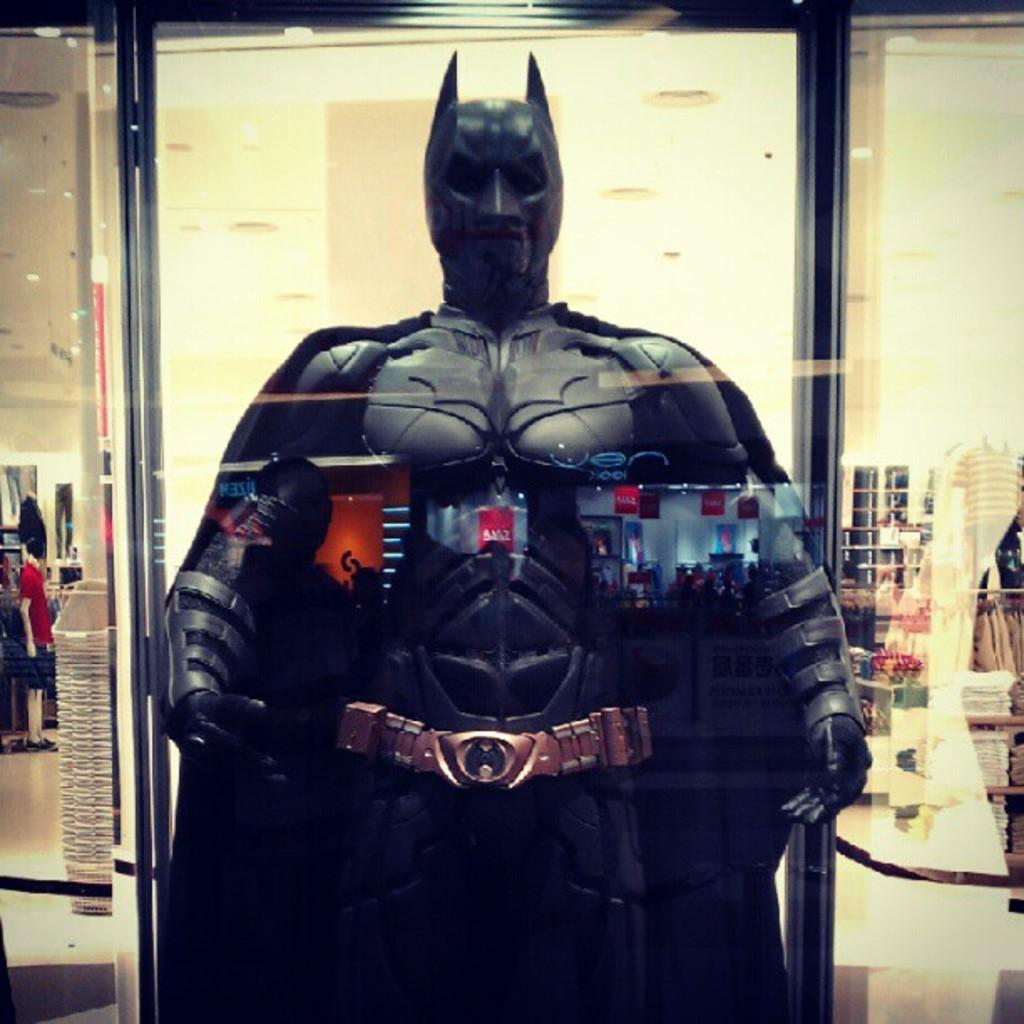What type of costume is visible in the image? There is a costume of a batman in the image. What color is the batman costume? The costume is black in color. What can be seen in the background of the image? There is a wall in the background of the image. Did the earthquake cause any damage to the batman costume in the image? There is no mention of an earthquake or any damage to the costume in the image. 